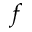Convert formula to latex. <formula><loc_0><loc_0><loc_500><loc_500>f</formula> 